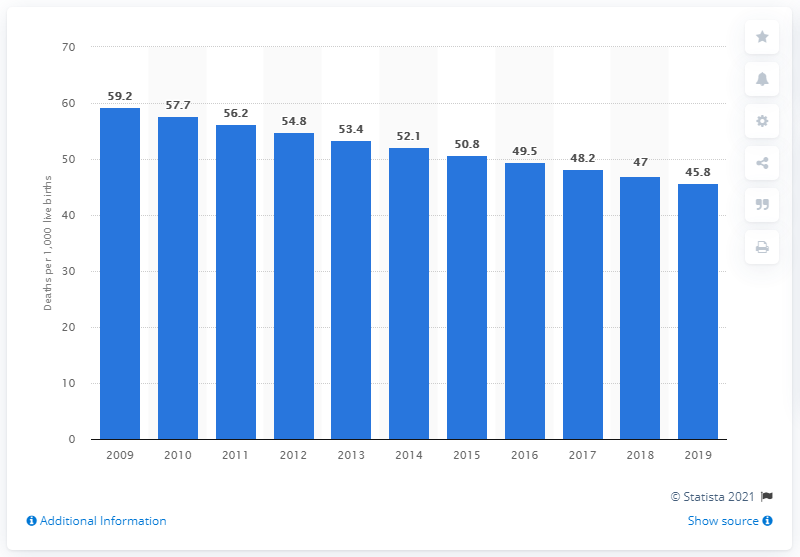Highlight a few significant elements in this photo. The infant mortality rate in Togo in 2019 was 45.8 deaths per 1,000 live births. 